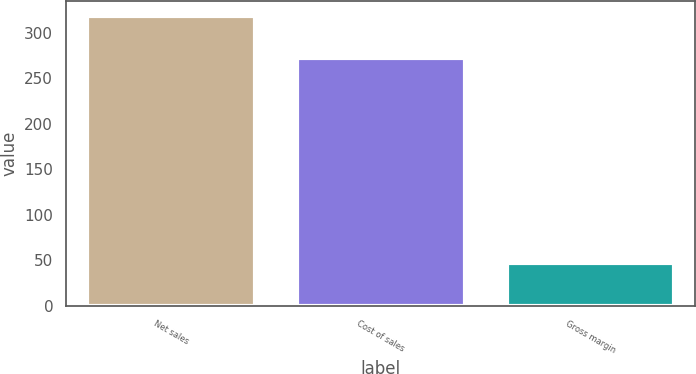Convert chart to OTSL. <chart><loc_0><loc_0><loc_500><loc_500><bar_chart><fcel>Net sales<fcel>Cost of sales<fcel>Gross margin<nl><fcel>319<fcel>272<fcel>47<nl></chart> 